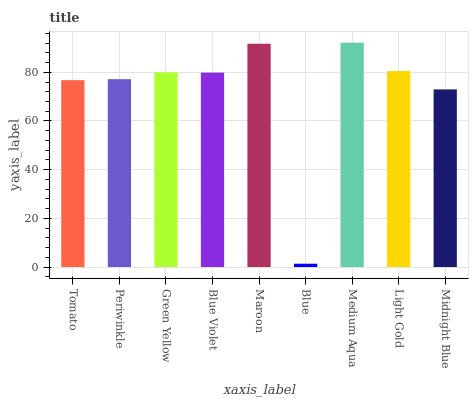Is Periwinkle the minimum?
Answer yes or no. No. Is Periwinkle the maximum?
Answer yes or no. No. Is Periwinkle greater than Tomato?
Answer yes or no. Yes. Is Tomato less than Periwinkle?
Answer yes or no. Yes. Is Tomato greater than Periwinkle?
Answer yes or no. No. Is Periwinkle less than Tomato?
Answer yes or no. No. Is Blue Violet the high median?
Answer yes or no. Yes. Is Blue Violet the low median?
Answer yes or no. Yes. Is Midnight Blue the high median?
Answer yes or no. No. Is Medium Aqua the low median?
Answer yes or no. No. 